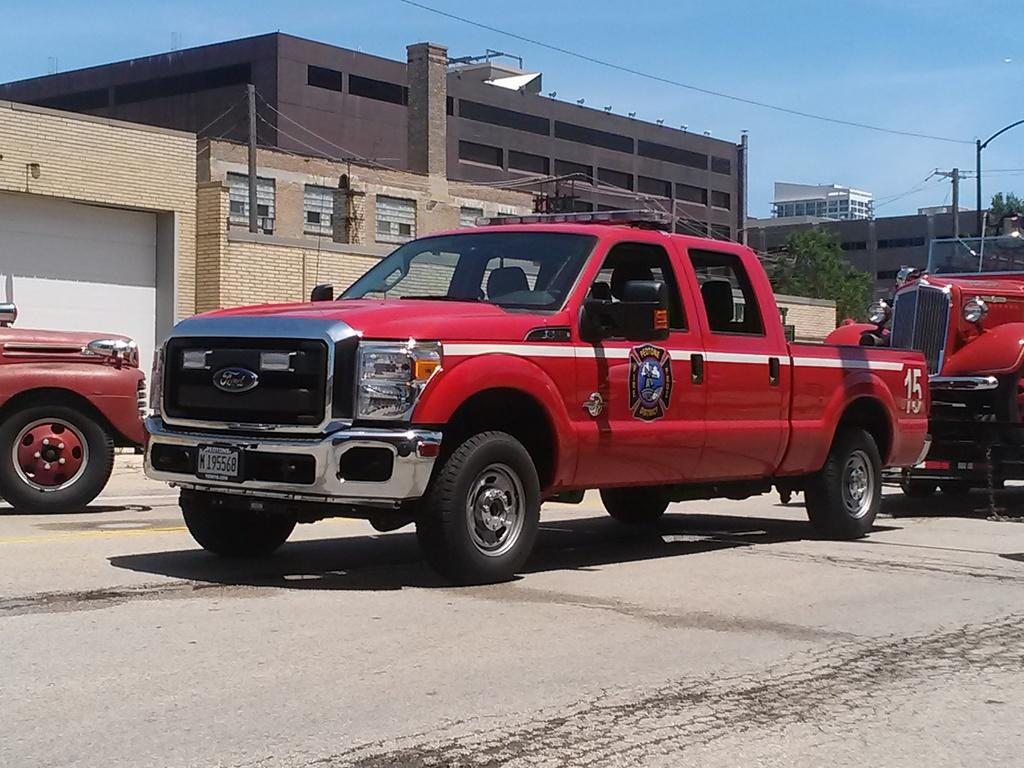What type of objects can be seen in the image? There are vehicles in the image. What color are the vehicles? The vehicles are red in color. Where are the vehicles located? The vehicles are on the road. What can be seen in the background of the image? There are trees, poles, buildings, and the sky visible in the background of the image. What type of comb is being used by the father in the image? There is no father or comb present in the image; it features red vehicles on the road with a background of trees, poles, buildings, and the sky. 